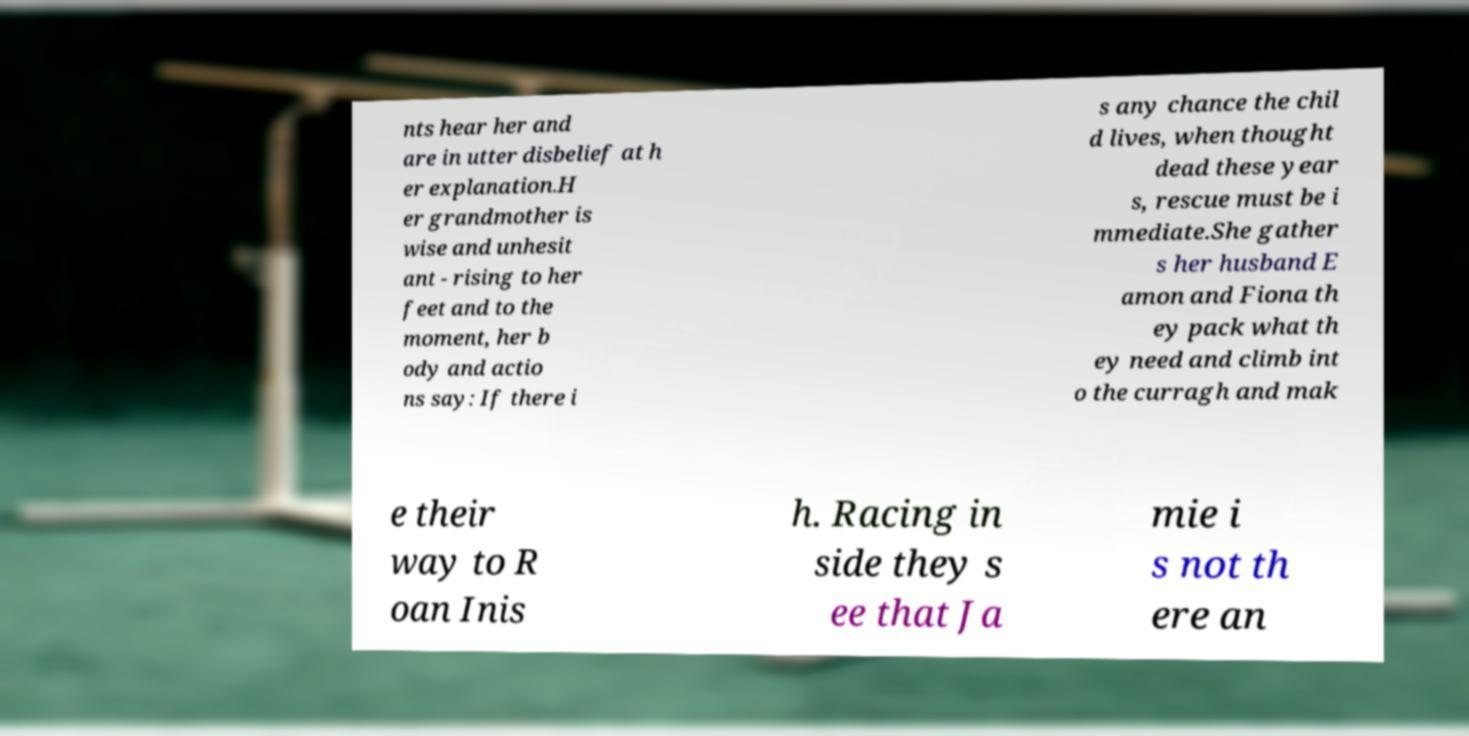Can you accurately transcribe the text from the provided image for me? nts hear her and are in utter disbelief at h er explanation.H er grandmother is wise and unhesit ant - rising to her feet and to the moment, her b ody and actio ns say: If there i s any chance the chil d lives, when thought dead these year s, rescue must be i mmediate.She gather s her husband E amon and Fiona th ey pack what th ey need and climb int o the curragh and mak e their way to R oan Inis h. Racing in side they s ee that Ja mie i s not th ere an 